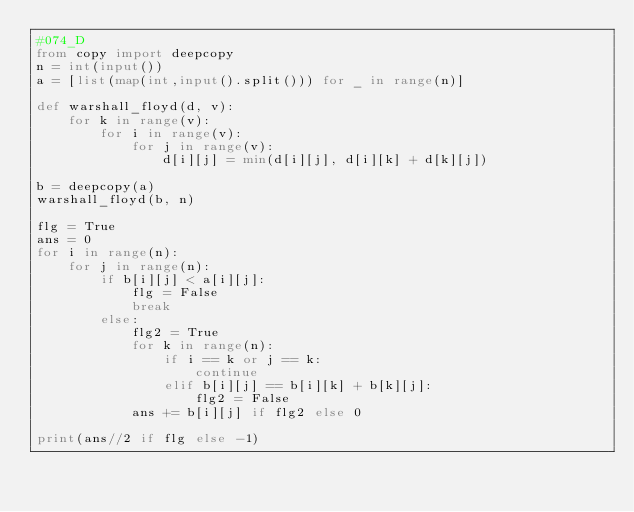Convert code to text. <code><loc_0><loc_0><loc_500><loc_500><_Python_>#074_D
from copy import deepcopy
n = int(input())
a = [list(map(int,input().split())) for _ in range(n)]

def warshall_floyd(d, v):
    for k in range(v):
        for i in range(v):
            for j in range(v):
                d[i][j] = min(d[i][j], d[i][k] + d[k][j])

b = deepcopy(a)
warshall_floyd(b, n)

flg = True
ans = 0
for i in range(n):
    for j in range(n):
        if b[i][j] < a[i][j]:
            flg = False
            break
        else:
            flg2 = True
            for k in range(n):
                if i == k or j == k:
                    continue
                elif b[i][j] == b[i][k] + b[k][j]:
                    flg2 = False
            ans += b[i][j] if flg2 else 0
                    
print(ans//2 if flg else -1)</code> 